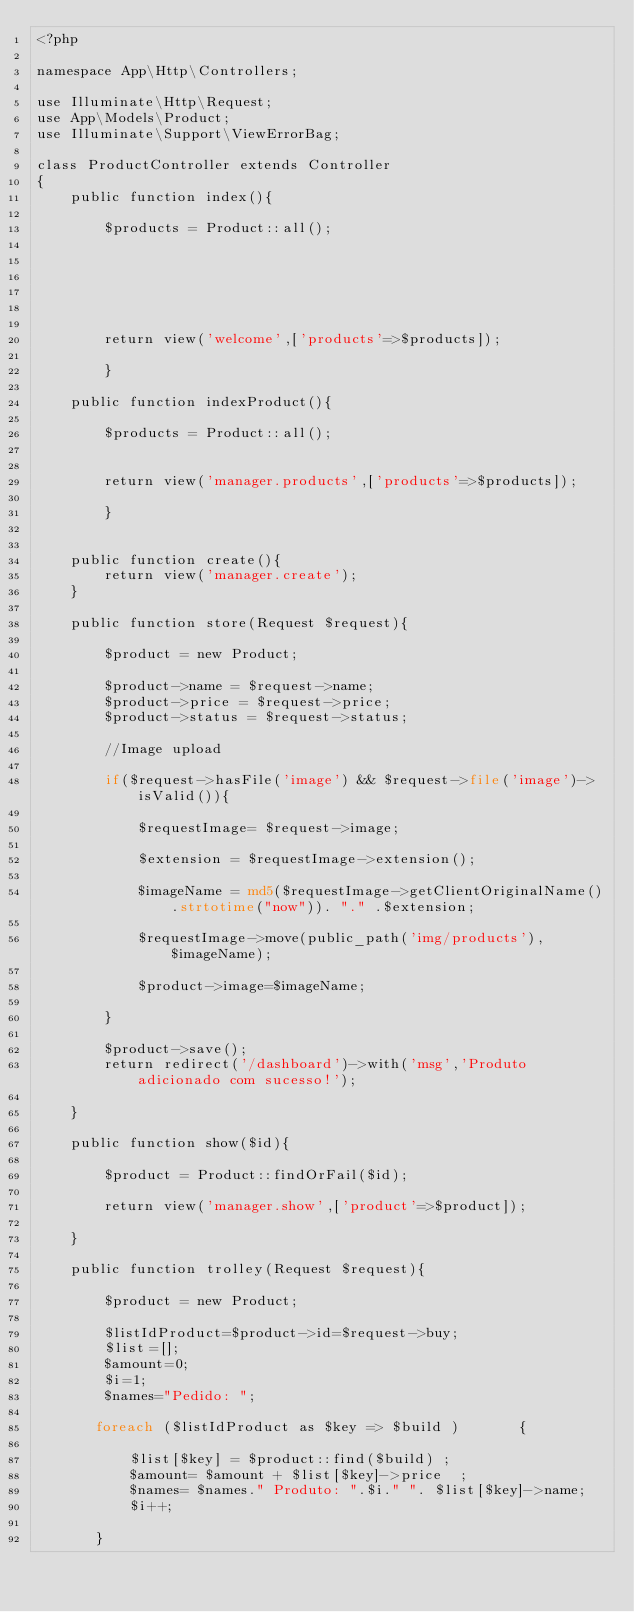Convert code to text. <code><loc_0><loc_0><loc_500><loc_500><_PHP_><?php

namespace App\Http\Controllers;

use Illuminate\Http\Request;
use App\Models\Product;
use Illuminate\Support\ViewErrorBag;

class ProductController extends Controller
{
    public function index(){

        $products = Product::all();
     
       

        
        

        return view('welcome',['products'=>$products]);
        
        }

    public function indexProduct(){

        $products = Product::all();
            
    
        return view('manager.products',['products'=>$products]);
            
        }   
        

    public function create(){
        return view('manager.create');
    }

    public function store(Request $request){

        $product = new Product;

        $product->name = $request->name;
        $product->price = $request->price;
        $product->status = $request->status;

        //Image upload

        if($request->hasFile('image') && $request->file('image')->isValid()){

            $requestImage= $request->image;

            $extension = $requestImage->extension();

            $imageName = md5($requestImage->getClientOriginalName().strtotime("now")). "." .$extension;

            $requestImage->move(public_path('img/products'),$imageName);

            $product->image=$imageName;

        }

        $product->save();
        return redirect('/dashboard')->with('msg','Produto adicionado com sucesso!');

    }

    public function show($id){

        $product = Product::findOrFail($id);

        return view('manager.show',['product'=>$product]);

    }

    public function trolley(Request $request){

        $product = new Product;

        $listIdProduct=$product->id=$request->buy;  
        $list=[];
        $amount=0;
        $i=1;      
        $names="Pedido: ";
        
       foreach ($listIdProduct as $key => $build )       {
           
           $list[$key] = $product::find($build) ;  
           $amount= $amount + $list[$key]->price  ; 
           $names= $names." Produto: ".$i." ". $list[$key]->name;
           $i++;
           
       }</code> 